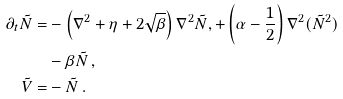Convert formula to latex. <formula><loc_0><loc_0><loc_500><loc_500>\partial _ { t } \tilde { N } = & - \left ( \nabla ^ { 2 } + \eta + 2 \sqrt { \beta } \right ) \nabla ^ { 2 } \tilde { N } , + \left ( \alpha - \frac { 1 } { 2 } \right ) \nabla ^ { 2 } ( \tilde { N } ^ { 2 } ) \\ & - \beta \tilde { N } \, , \\ \tilde { V } = & - \tilde { N } \, .</formula> 